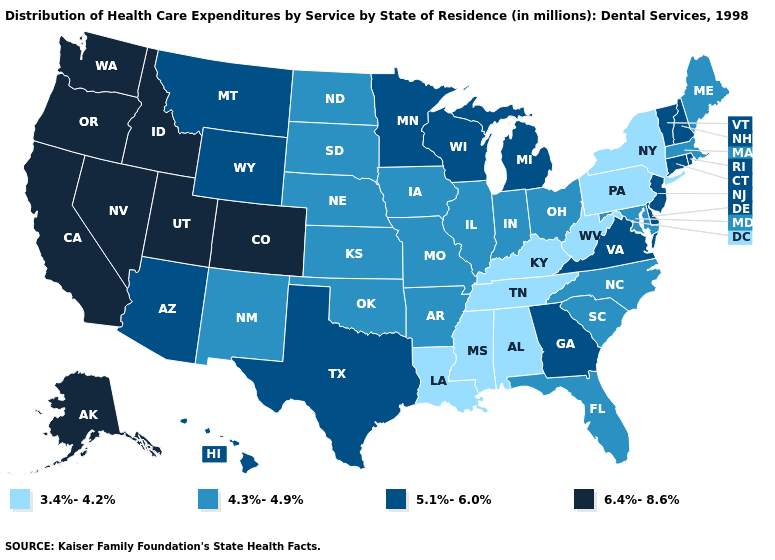Does Michigan have a higher value than Washington?
Concise answer only. No. Name the states that have a value in the range 4.3%-4.9%?
Give a very brief answer. Arkansas, Florida, Illinois, Indiana, Iowa, Kansas, Maine, Maryland, Massachusetts, Missouri, Nebraska, New Mexico, North Carolina, North Dakota, Ohio, Oklahoma, South Carolina, South Dakota. Does New Jersey have the same value as Wyoming?
Write a very short answer. Yes. Name the states that have a value in the range 3.4%-4.2%?
Be succinct. Alabama, Kentucky, Louisiana, Mississippi, New York, Pennsylvania, Tennessee, West Virginia. Which states have the highest value in the USA?
Quick response, please. Alaska, California, Colorado, Idaho, Nevada, Oregon, Utah, Washington. What is the value of Hawaii?
Be succinct. 5.1%-6.0%. Name the states that have a value in the range 6.4%-8.6%?
Concise answer only. Alaska, California, Colorado, Idaho, Nevada, Oregon, Utah, Washington. Name the states that have a value in the range 4.3%-4.9%?
Short answer required. Arkansas, Florida, Illinois, Indiana, Iowa, Kansas, Maine, Maryland, Massachusetts, Missouri, Nebraska, New Mexico, North Carolina, North Dakota, Ohio, Oklahoma, South Carolina, South Dakota. What is the value of Connecticut?
Answer briefly. 5.1%-6.0%. What is the value of Tennessee?
Give a very brief answer. 3.4%-4.2%. What is the highest value in the USA?
Concise answer only. 6.4%-8.6%. Which states have the highest value in the USA?
Be succinct. Alaska, California, Colorado, Idaho, Nevada, Oregon, Utah, Washington. Among the states that border Wyoming , does Colorado have the lowest value?
Give a very brief answer. No. Name the states that have a value in the range 6.4%-8.6%?
Concise answer only. Alaska, California, Colorado, Idaho, Nevada, Oregon, Utah, Washington. Name the states that have a value in the range 5.1%-6.0%?
Short answer required. Arizona, Connecticut, Delaware, Georgia, Hawaii, Michigan, Minnesota, Montana, New Hampshire, New Jersey, Rhode Island, Texas, Vermont, Virginia, Wisconsin, Wyoming. 